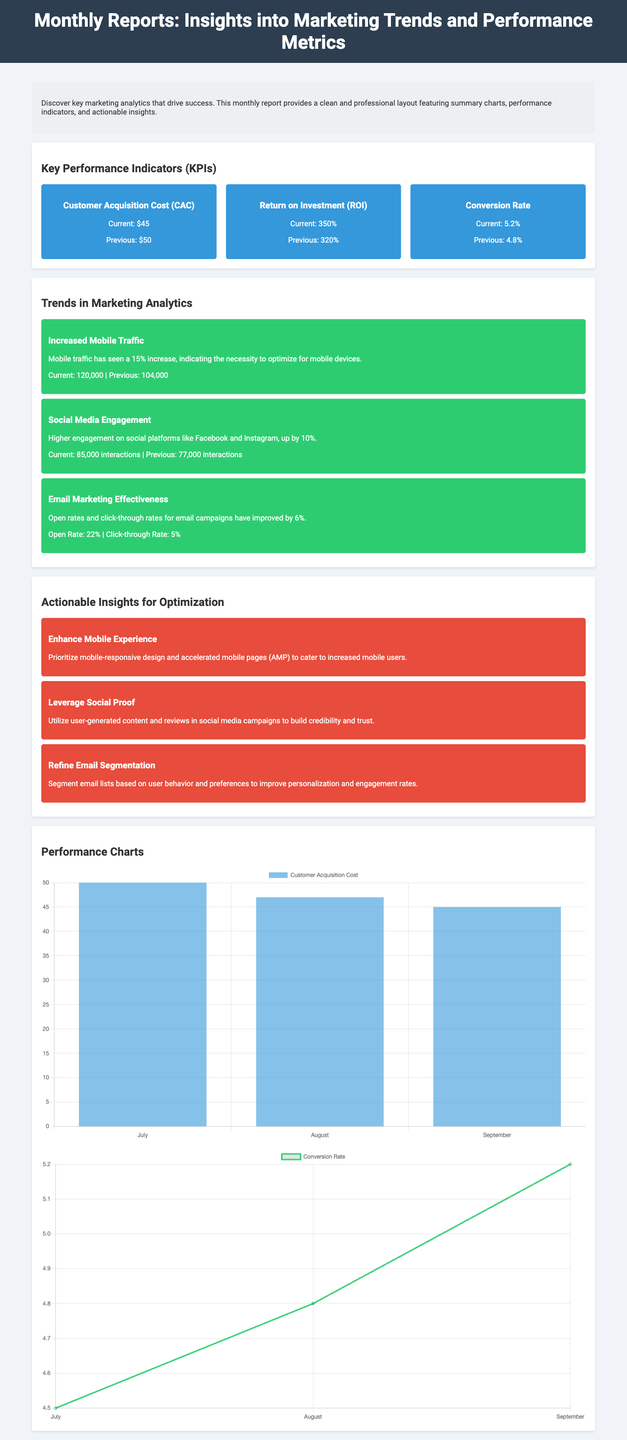What is the current Customer Acquisition Cost? The current Customer Acquisition Cost is listed in the KPIs section of the document.
Answer: $45 What was the previous Return on Investment? The previous Return on Investment can be found in the same KPIs section.
Answer: 320% How much has mobile traffic increased? The mobile traffic increase is mentioned in the Trends section, providing a specific percentage.
Answer: 15% What is the open rate for email marketing campaigns? The open rate for email marketing campaigns is stated in the Trends section.
Answer: 22% What action is suggested for enhancing mobile experience? The insight for mobile experience improvement is highlighted in the Actionable Insights section.
Answer: Prioritize mobile-responsive design What is the trend in social media engagement? The trend in social media engagement is described alongside a specific percentage increase in the document.
Answer: Up by 10% How many interactions were there on social media platforms currently? The current interactions on social media platforms are provided in the Trends section.
Answer: 85,000 interactions What chart type is used for the Customer Acquisition Cost? The type of the chart is specified when describing the performance charts in the document.
Answer: Bar What is the title of the report? The title can be found at the top of the document in the header section.
Answer: Monthly Reports: Insights into Marketing Trends and Performance Metrics What is the concise description provided in the overview? The overview section contains a brief description of what the report entails.
Answer: Discover key marketing analytics that drive success 